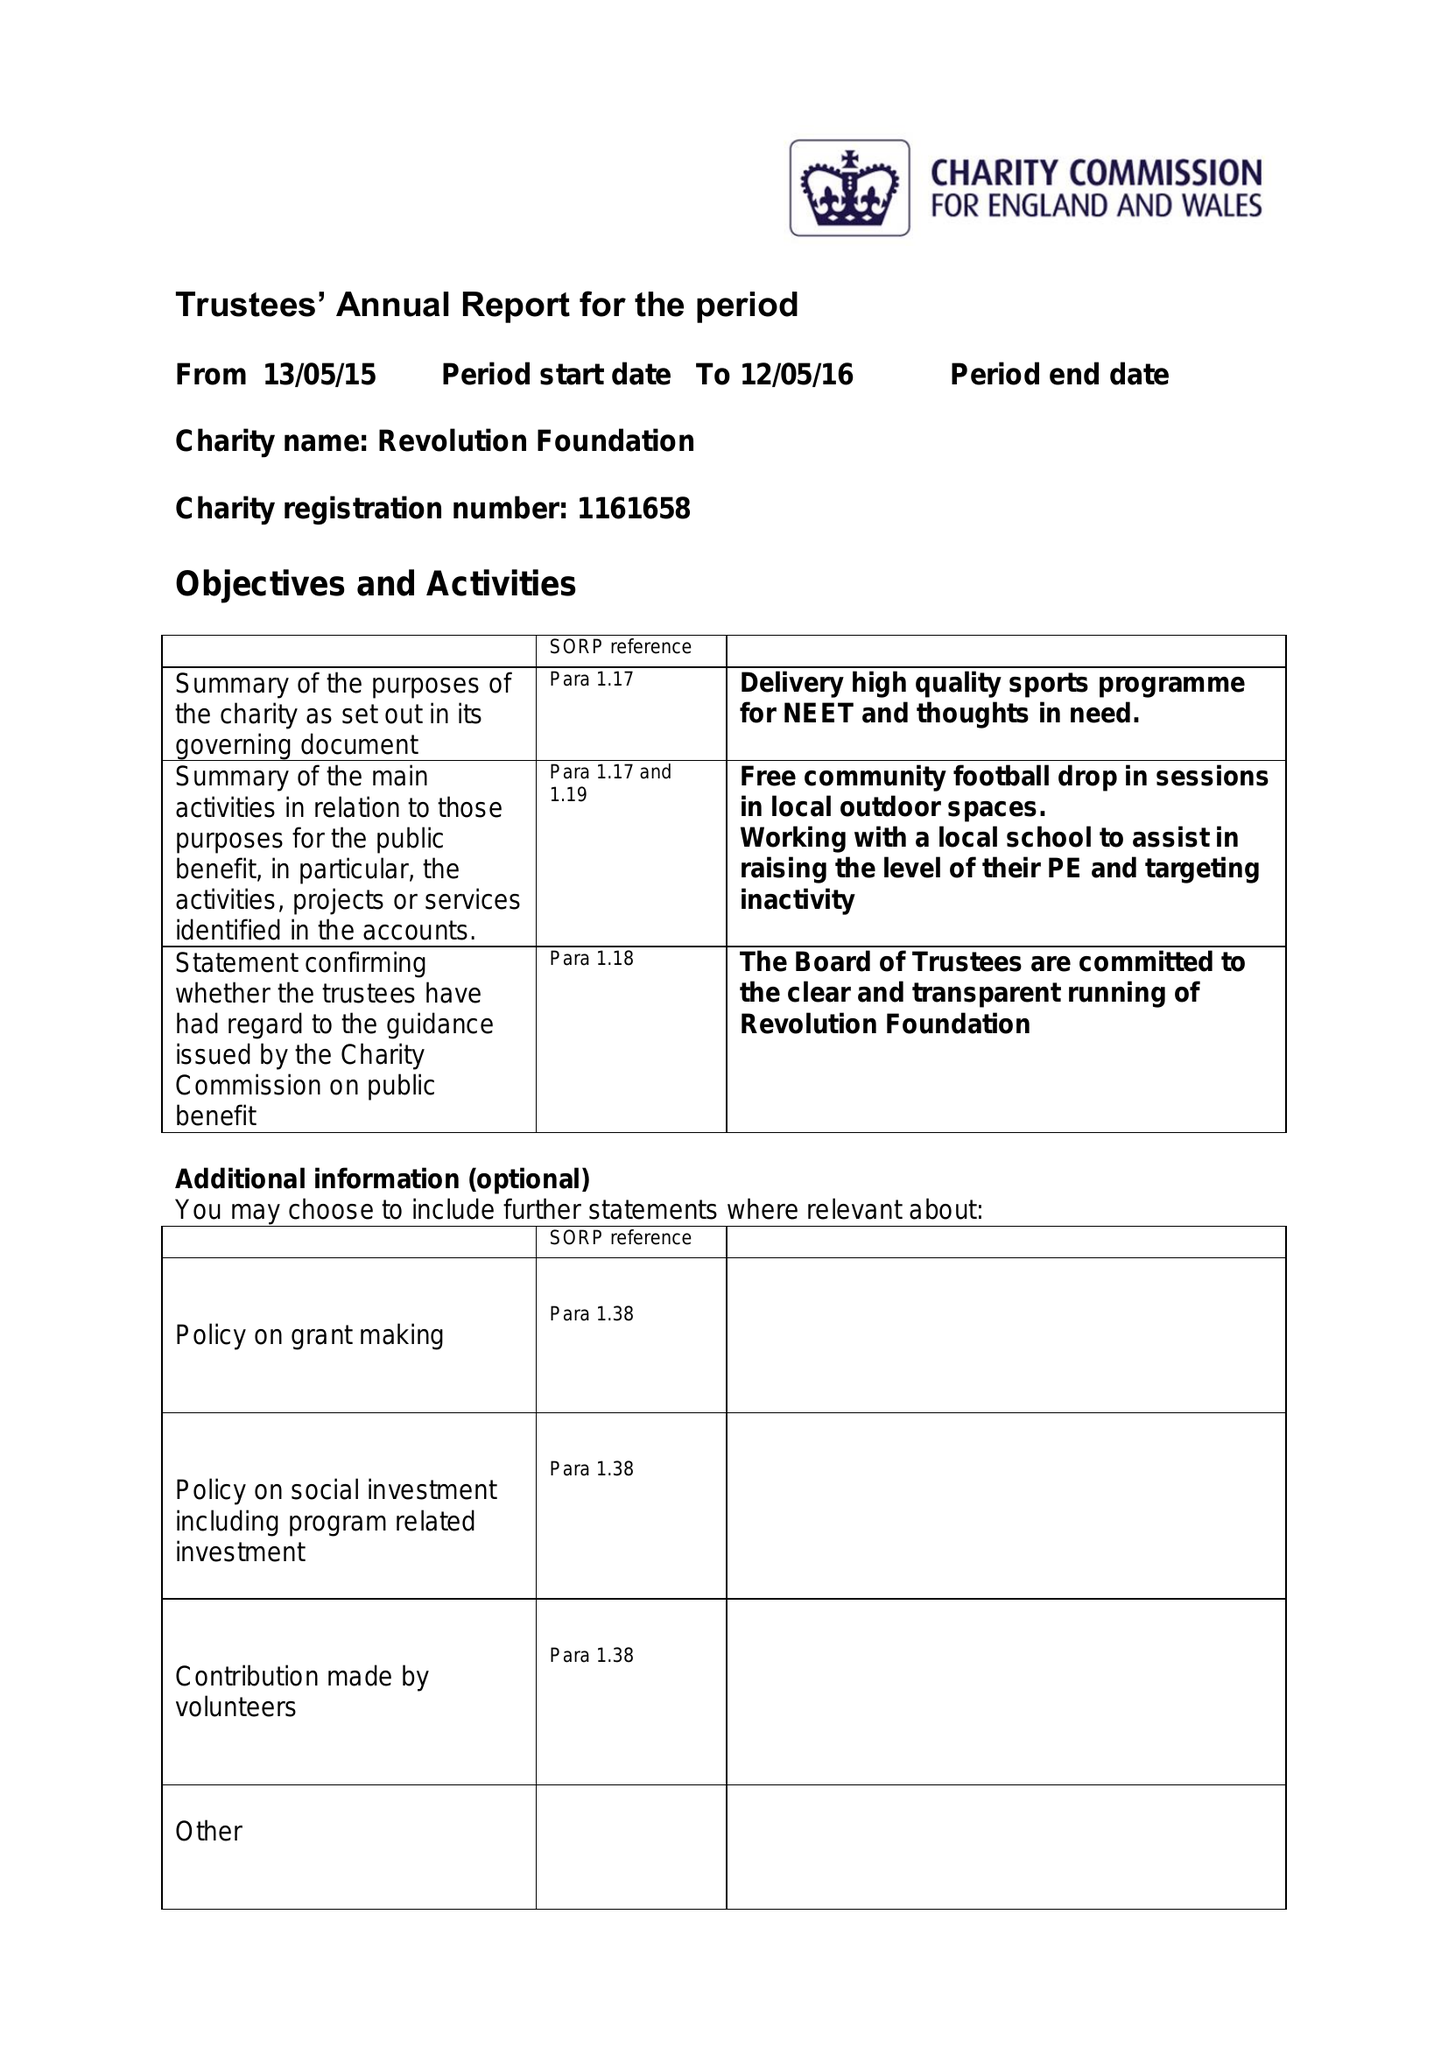What is the value for the address__postcode?
Answer the question using a single word or phrase. DA8 1QB 